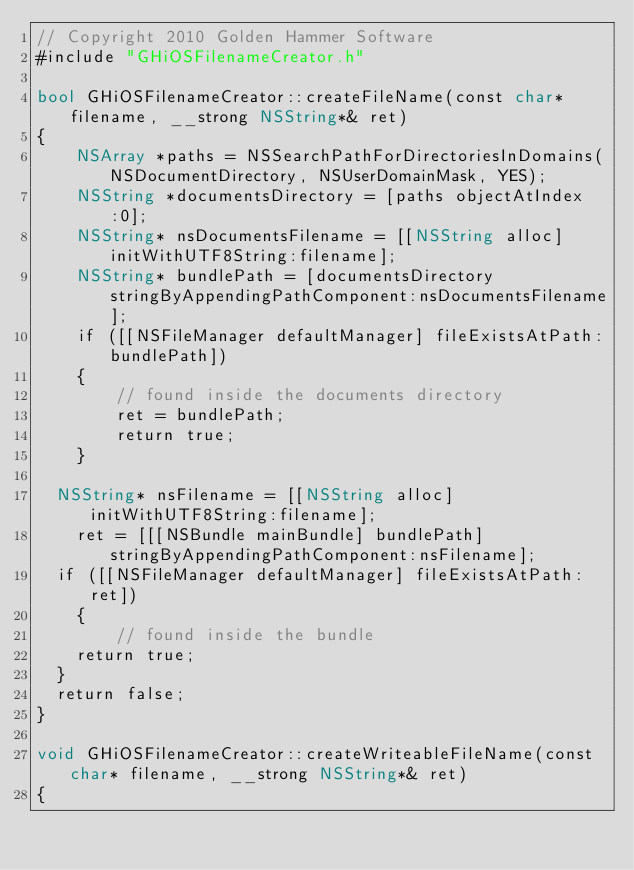Convert code to text. <code><loc_0><loc_0><loc_500><loc_500><_ObjectiveC_>// Copyright 2010 Golden Hammer Software
#include "GHiOSFilenameCreator.h"

bool GHiOSFilenameCreator::createFileName(const char* filename, __strong NSString*& ret)
{
    NSArray *paths = NSSearchPathForDirectoriesInDomains(NSDocumentDirectory, NSUserDomainMask, YES);
    NSString *documentsDirectory = [paths objectAtIndex:0];
    NSString* nsDocumentsFilename = [[NSString alloc] initWithUTF8String:filename];
    NSString* bundlePath = [documentsDirectory stringByAppendingPathComponent:nsDocumentsFilename];
    if ([[NSFileManager defaultManager] fileExistsAtPath:bundlePath])
    {
        // found inside the documents directory
        ret = bundlePath;
        return true;
    }
    
	NSString* nsFilename = [[NSString alloc] initWithUTF8String:filename];
    ret = [[[NSBundle mainBundle] bundlePath] stringByAppendingPathComponent:nsFilename];
	if ([[NSFileManager defaultManager] fileExistsAtPath:ret])
    {
        // found inside the bundle
		return true;
	}
	return false;
}

void GHiOSFilenameCreator::createWriteableFileName(const char* filename, __strong NSString*& ret)
{</code> 